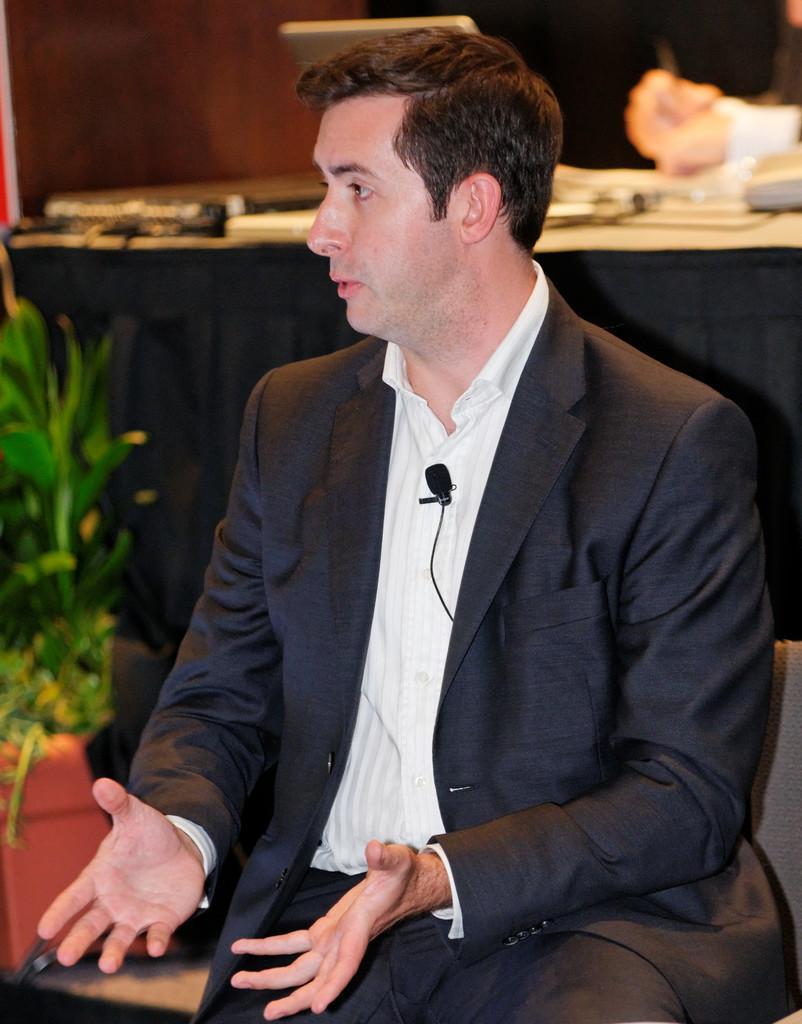Can you describe this image briefly? In this image I can see a person. On the left side I can see a plant. I can see some objects on the table. 